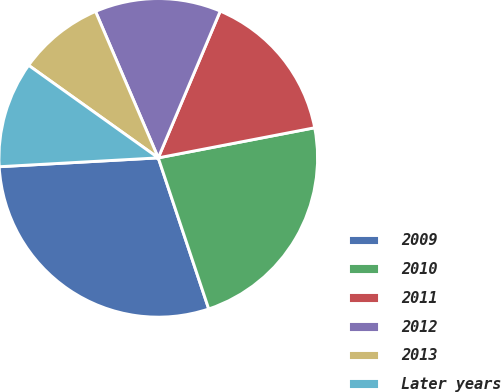Convert chart. <chart><loc_0><loc_0><loc_500><loc_500><pie_chart><fcel>2009<fcel>2010<fcel>2011<fcel>2012<fcel>2013<fcel>Later years<nl><fcel>29.24%<fcel>22.89%<fcel>15.61%<fcel>12.8%<fcel>8.69%<fcel>10.75%<nl></chart> 